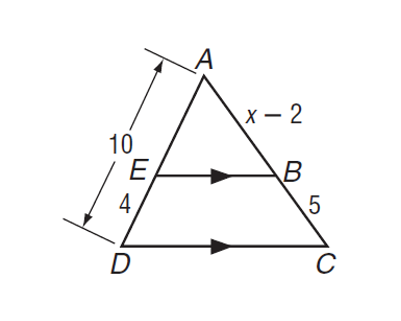Answer the mathemtical geometry problem and directly provide the correct option letter.
Question: If E B \parallel D C, find x.
Choices: A: 2 B: 4 C: 5 D: 9.5 D 